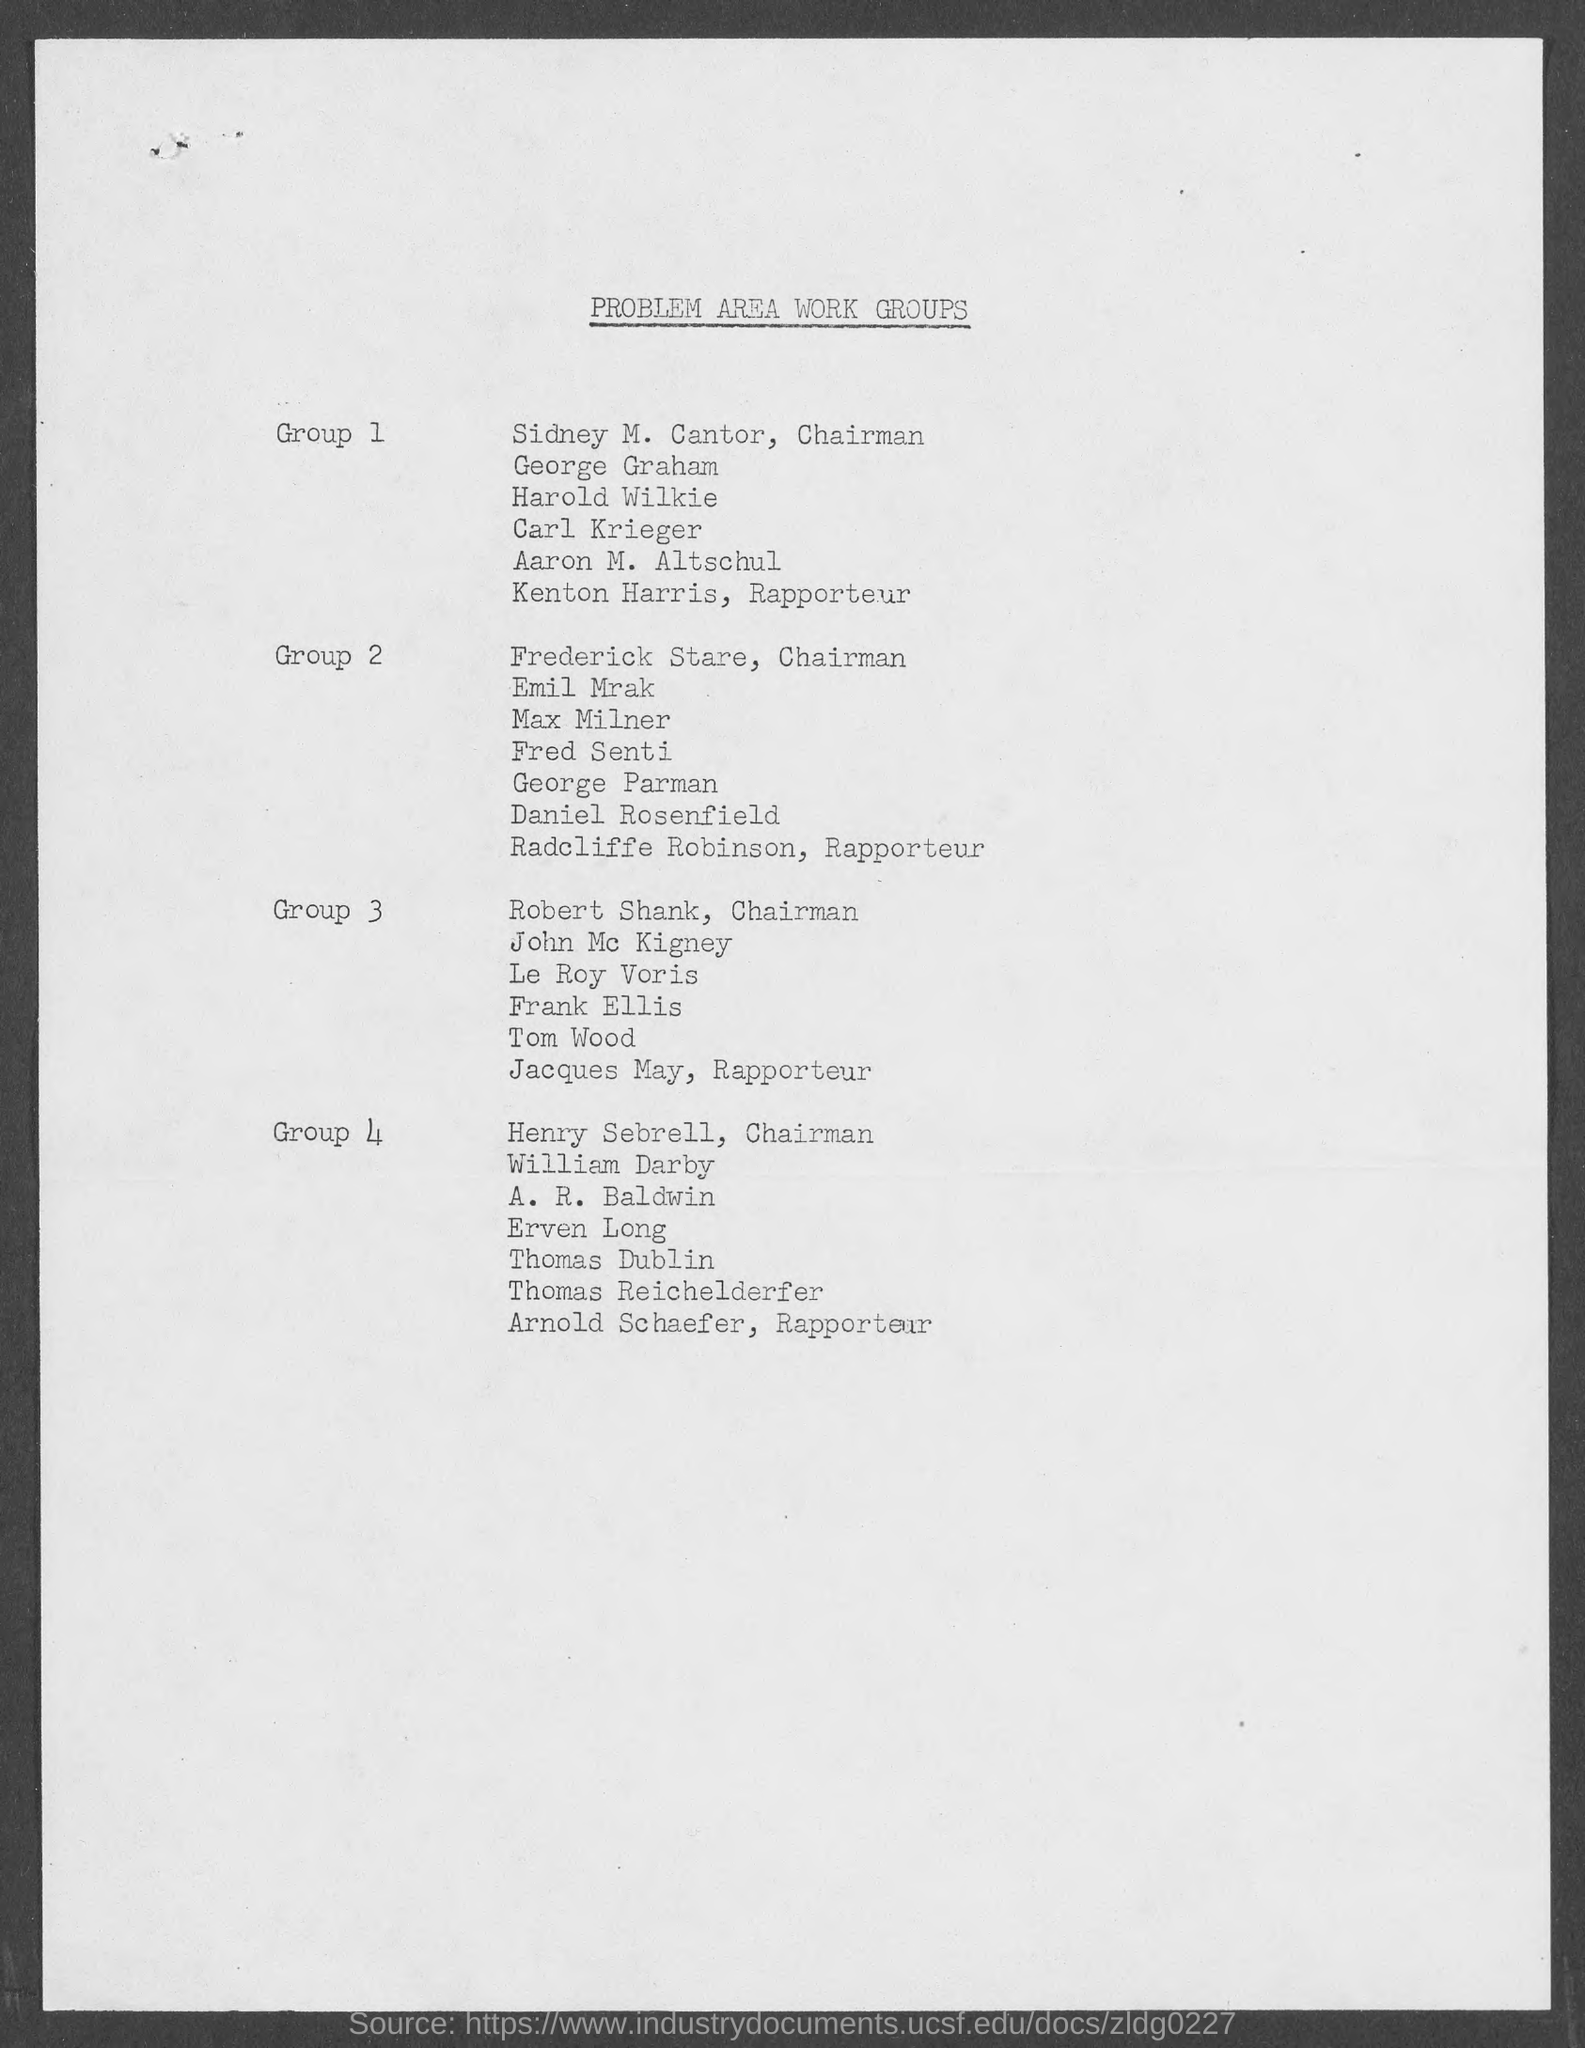Point out several critical features in this image. Radcliffe Robinson is the Rapporteur of Group 2. The document title is concerning the problem area work groups and their areas of concern. Henry Sebrell belongs to Group 4. Sidney M. Cantor is the chairman of Group 1. 